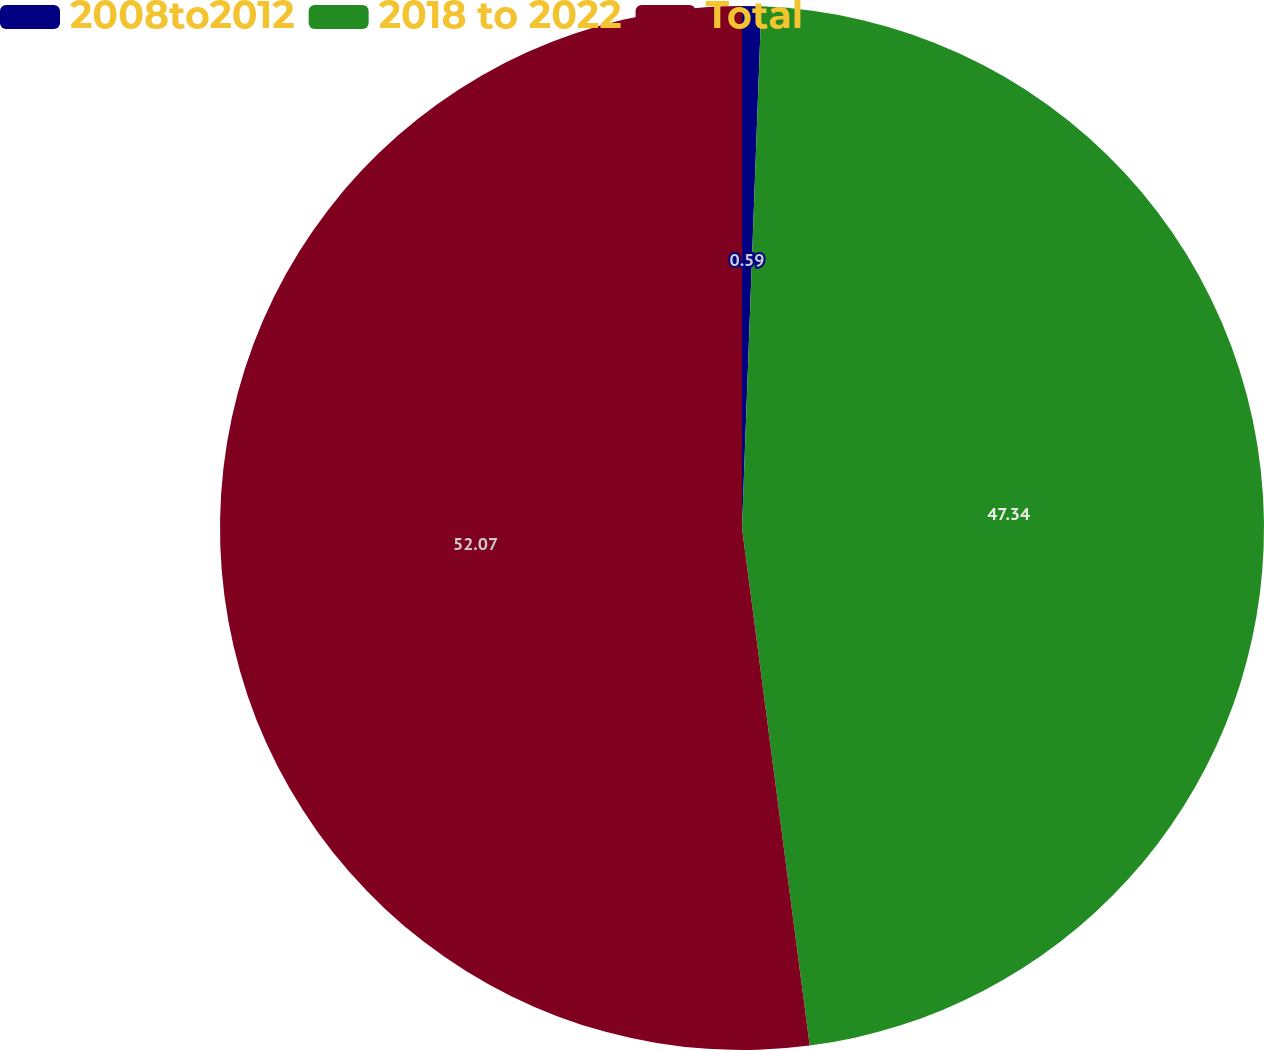Convert chart. <chart><loc_0><loc_0><loc_500><loc_500><pie_chart><fcel>2008to2012<fcel>2018 to 2022<fcel>Total<nl><fcel>0.59%<fcel>47.34%<fcel>52.07%<nl></chart> 